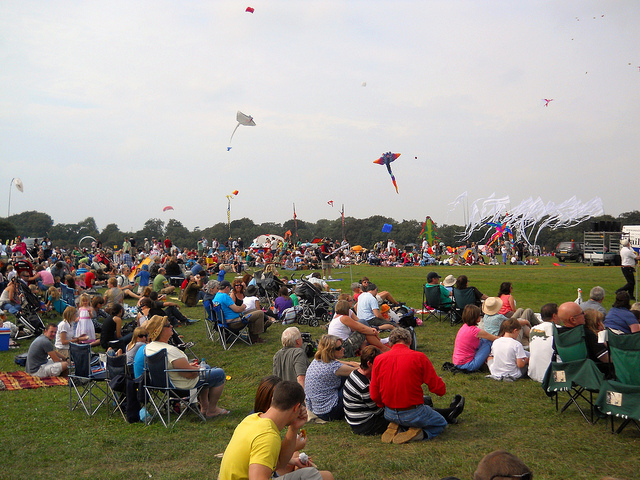Besides kite flying, what other activities might be common at events like these? Events like this one often include a range of activities to cater to a broad audience. These might include workshops on how to build and fly kites, food stalls where attendees can enjoy local cuisine, live music or entertainment for a festive atmosphere, and games or competitions to engage all age groups. Do gatherings like this have an impact on the local community? Absolutely, gatherings like this can have a positive impact by encouraging community engagement and local tourism. They offer an opportunity for people to come together to celebrate a shared hobby, support local artisans and vendors, and create lasting memories that foster a sense of local pride and unity. 